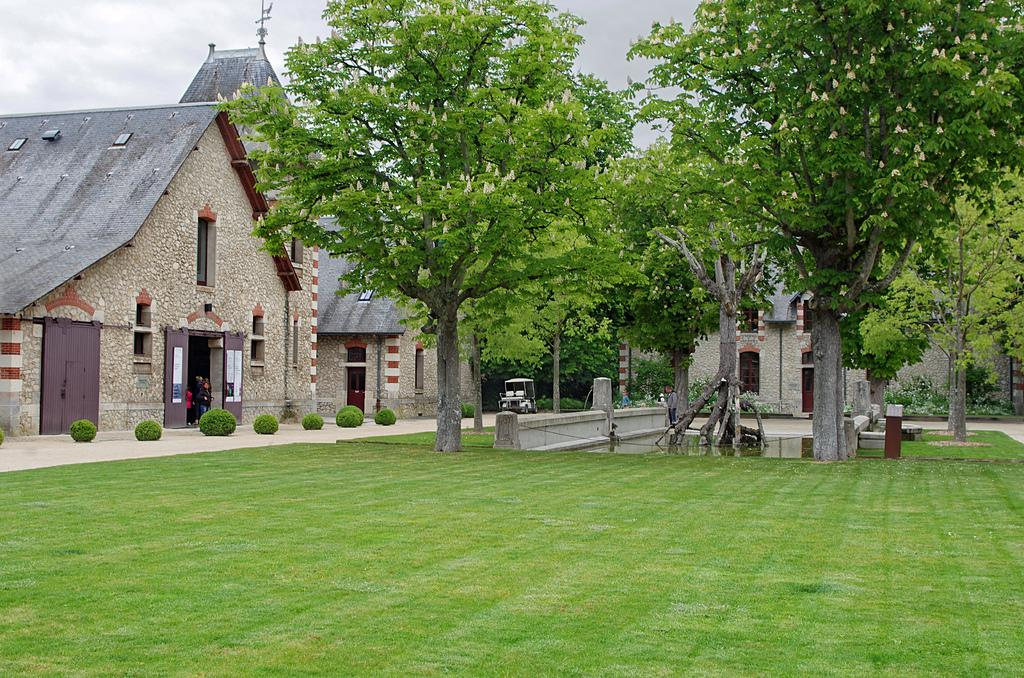What type of vegetation can be seen in the image? There is grass in the image. What other natural elements are present in the image? There are trees in the image. What type of man-made structures are visible in the image? There are buildings in the image. Are there any living beings present in the image? Yes, there are people in the image. What can be seen in the background of the image? There is a vehicle visible in the background of the image. How does the grass blow in the image? The grass does not blow in the image; it is stationary. 